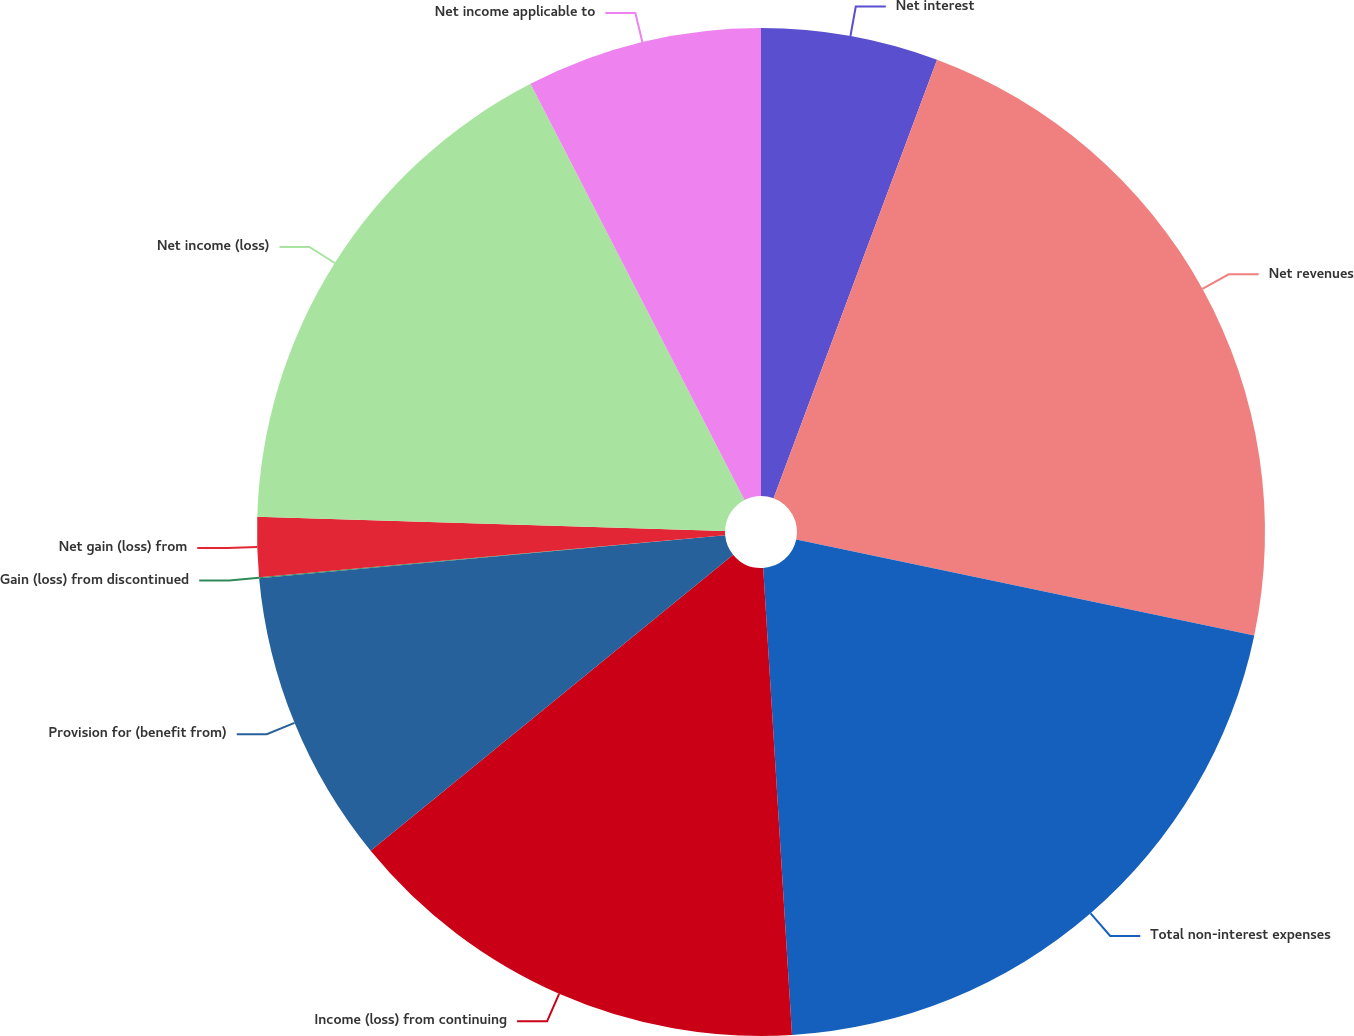Convert chart to OTSL. <chart><loc_0><loc_0><loc_500><loc_500><pie_chart><fcel>Net interest<fcel>Net revenues<fcel>Total non-interest expenses<fcel>Income (loss) from continuing<fcel>Provision for (benefit from)<fcel>Gain (loss) from discontinued<fcel>Net gain (loss) from<fcel>Net income (loss)<fcel>Net income applicable to<nl><fcel>5.68%<fcel>22.61%<fcel>20.73%<fcel>15.08%<fcel>9.44%<fcel>0.03%<fcel>1.91%<fcel>16.96%<fcel>7.56%<nl></chart> 